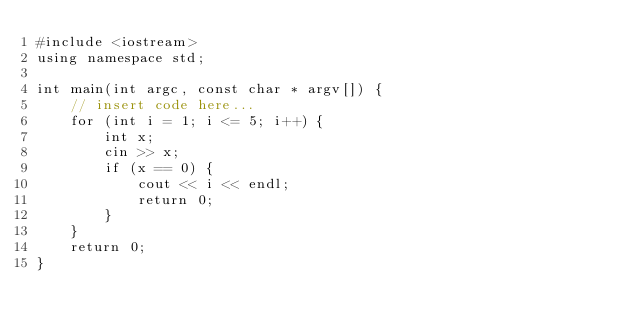Convert code to text. <code><loc_0><loc_0><loc_500><loc_500><_C++_>#include <iostream>
using namespace std;

int main(int argc, const char * argv[]) {
    // insert code here...
    for (int i = 1; i <= 5; i++) {
        int x;
        cin >> x;
        if (x == 0) {
            cout << i << endl;
            return 0;
        }
    }
    return 0;
}
</code> 